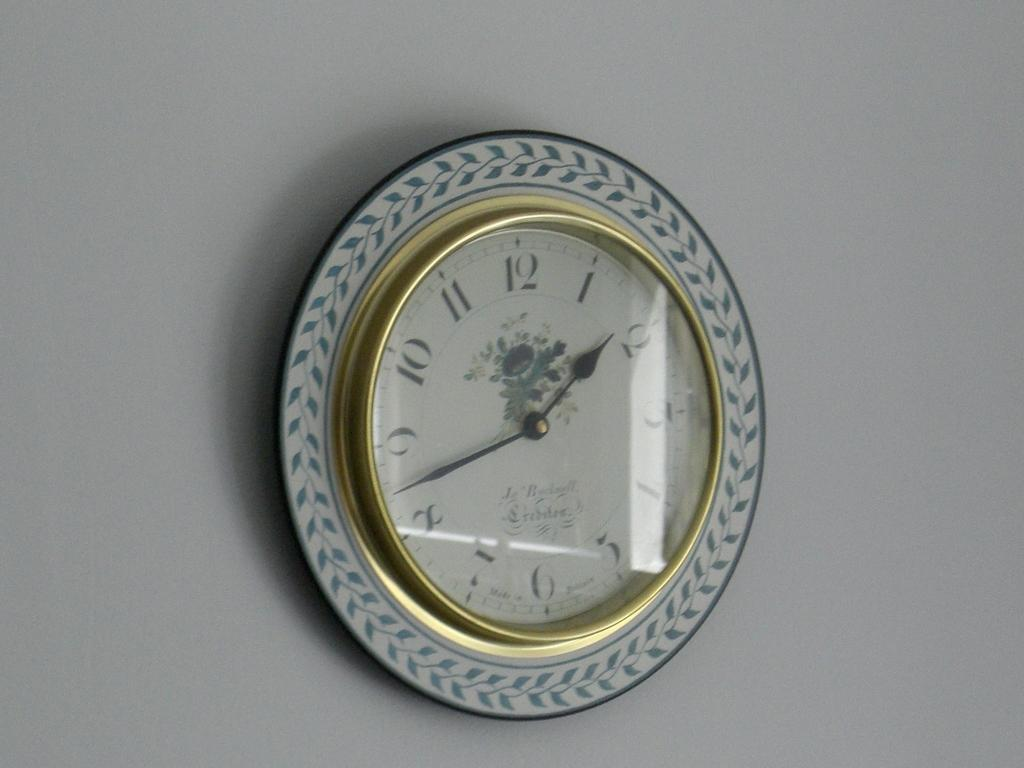<image>
Describe the image concisely. A fancy wall clock with the time showing 1:43. 